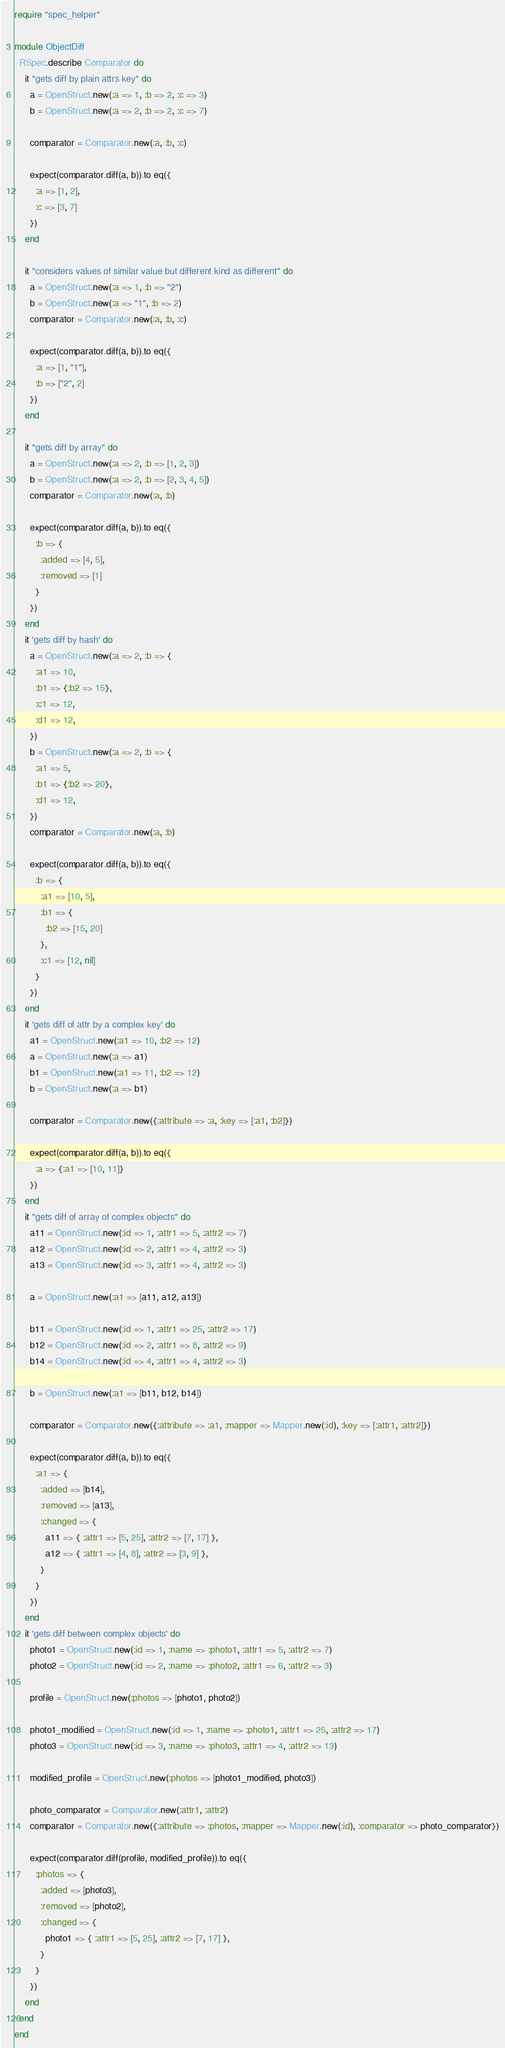Convert code to text. <code><loc_0><loc_0><loc_500><loc_500><_Ruby_>require "spec_helper"

module ObjectDiff
  RSpec.describe Comparator do
    it "gets diff by plain attrs key" do
      a = OpenStruct.new(:a => 1, :b => 2, :c => 3)
      b = OpenStruct.new(:a => 2, :b => 2, :c => 7)

      comparator = Comparator.new(:a, :b, :c)

      expect(comparator.diff(a, b)).to eq({
        :a => [1, 2],
        :c => [3, 7]
      })
    end

    it "considers values of similar value but different kind as different" do
      a = OpenStruct.new(:a => 1, :b => "2")
      b = OpenStruct.new(:a => "1", :b => 2)
      comparator = Comparator.new(:a, :b, :c)

      expect(comparator.diff(a, b)).to eq({
        :a => [1, "1"],
        :b => ["2", 2]
      })
    end

    it "gets diff by array" do
      a = OpenStruct.new(:a => 2, :b => [1, 2, 3])
      b = OpenStruct.new(:a => 2, :b => [2, 3, 4, 5])
      comparator = Comparator.new(:a, :b)

      expect(comparator.diff(a, b)).to eq({
        :b => {
          :added => [4, 5],
          :removed => [1]
        }
      })
    end
    it 'gets diff by hash' do
      a = OpenStruct.new(:a => 2, :b => {
        :a1 => 10,
        :b1 => {:b2 => 15},
        :c1 => 12,
        :d1 => 12,
      })
      b = OpenStruct.new(:a => 2, :b => {
        :a1 => 5,
        :b1 => {:b2 => 20},
        :d1 => 12,
      })
      comparator = Comparator.new(:a, :b)

      expect(comparator.diff(a, b)).to eq({
        :b => {
          :a1 => [10, 5],
          :b1 => {
            :b2 => [15, 20]
          },
          :c1 => [12, nil]
        }
      })
    end
    it 'gets diff of attr by a complex key' do
      a1 = OpenStruct.new(:a1 => 10, :b2 => 12)
      a = OpenStruct.new(:a => a1)
      b1 = OpenStruct.new(:a1 => 11, :b2 => 12)
      b = OpenStruct.new(:a => b1)

      comparator = Comparator.new({:attribute => :a, :key => [:a1, :b2]})

      expect(comparator.diff(a, b)).to eq({
        :a => {:a1 => [10, 11]}
      })
    end
    it "gets diff of array of complex objects" do
      a11 = OpenStruct.new(:id => 1, :attr1 => 5, :attr2 => 7)
      a12 = OpenStruct.new(:id => 2, :attr1 => 4, :attr2 => 3)
      a13 = OpenStruct.new(:id => 3, :attr1 => 4, :attr2 => 3)

      a = OpenStruct.new(:a1 => [a11, a12, a13])

      b11 = OpenStruct.new(:id => 1, :attr1 => 25, :attr2 => 17)
      b12 = OpenStruct.new(:id => 2, :attr1 => 8, :attr2 => 9)
      b14 = OpenStruct.new(:id => 4, :attr1 => 4, :attr2 => 3)

      b = OpenStruct.new(:a1 => [b11, b12, b14])

      comparator = Comparator.new({:attribute => :a1, :mapper => Mapper.new(:id), :key => [:attr1, :attr2]})

      expect(comparator.diff(a, b)).to eq({
        :a1 => {
          :added => [b14],
          :removed => [a13],
          :changed => {
            a11 => { :attr1 => [5, 25], :attr2 => [7, 17] },
            a12 => { :attr1 => [4, 8], :attr2 => [3, 9] },
          }
        }
      })
    end
    it 'gets diff between complex objects' do
      photo1 = OpenStruct.new(:id => 1, :name => :photo1, :attr1 => 5, :attr2 => 7)
      photo2 = OpenStruct.new(:id => 2, :name => :photo2, :attr1 => 6, :attr2 => 3)

      profile = OpenStruct.new(:photos => [photo1, photo2])

      photo1_modified = OpenStruct.new(:id => 1, :name => :photo1, :attr1 => 25, :attr2 => 17)
      photo3 = OpenStruct.new(:id => 3, :name => :photo3, :attr1 => 4, :attr2 => 13)

      modified_profile = OpenStruct.new(:photos => [photo1_modified, photo3])

      photo_comparator = Comparator.new(:attr1, :attr2)
      comparator = Comparator.new({:attribute => :photos, :mapper => Mapper.new(:id), :comparator => photo_comparator})

      expect(comparator.diff(profile, modified_profile)).to eq({
        :photos => {
          :added => [photo3],
          :removed => [photo2],
          :changed => {
            photo1 => { :attr1 => [5, 25], :attr2 => [7, 17] },
          }
        }
      })
    end
  end
end
</code> 